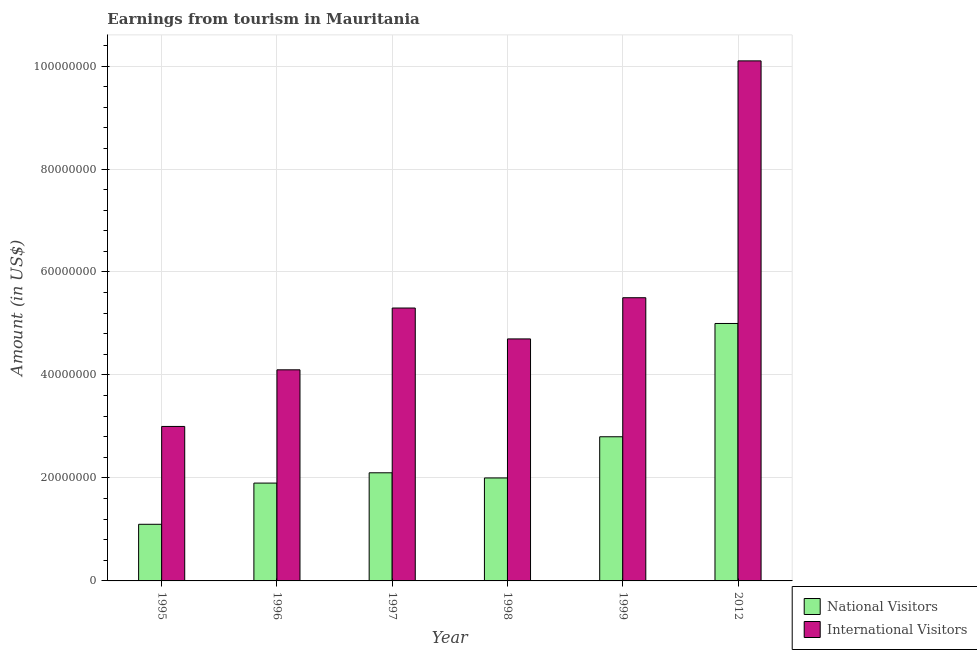Are the number of bars per tick equal to the number of legend labels?
Your response must be concise. Yes. Are the number of bars on each tick of the X-axis equal?
Make the answer very short. Yes. How many bars are there on the 4th tick from the left?
Provide a short and direct response. 2. What is the label of the 2nd group of bars from the left?
Make the answer very short. 1996. In how many cases, is the number of bars for a given year not equal to the number of legend labels?
Offer a terse response. 0. What is the amount earned from national visitors in 1997?
Offer a very short reply. 2.10e+07. Across all years, what is the maximum amount earned from international visitors?
Offer a very short reply. 1.01e+08. Across all years, what is the minimum amount earned from national visitors?
Make the answer very short. 1.10e+07. In which year was the amount earned from international visitors minimum?
Offer a very short reply. 1995. What is the total amount earned from national visitors in the graph?
Offer a terse response. 1.49e+08. What is the difference between the amount earned from national visitors in 1995 and that in 1999?
Keep it short and to the point. -1.70e+07. What is the difference between the amount earned from national visitors in 1996 and the amount earned from international visitors in 1995?
Your response must be concise. 8.00e+06. What is the average amount earned from international visitors per year?
Your response must be concise. 5.45e+07. In the year 1998, what is the difference between the amount earned from international visitors and amount earned from national visitors?
Your answer should be compact. 0. In how many years, is the amount earned from international visitors greater than 100000000 US$?
Your answer should be compact. 1. What is the ratio of the amount earned from international visitors in 1997 to that in 1998?
Your response must be concise. 1.13. What is the difference between the highest and the second highest amount earned from international visitors?
Offer a terse response. 4.60e+07. What is the difference between the highest and the lowest amount earned from international visitors?
Your answer should be compact. 7.10e+07. What does the 1st bar from the left in 1998 represents?
Keep it short and to the point. National Visitors. What does the 1st bar from the right in 2012 represents?
Provide a succinct answer. International Visitors. How many bars are there?
Your answer should be compact. 12. Are all the bars in the graph horizontal?
Provide a short and direct response. No. How many years are there in the graph?
Provide a succinct answer. 6. What is the difference between two consecutive major ticks on the Y-axis?
Provide a succinct answer. 2.00e+07. Are the values on the major ticks of Y-axis written in scientific E-notation?
Offer a terse response. No. Does the graph contain any zero values?
Your answer should be very brief. No. Does the graph contain grids?
Keep it short and to the point. Yes. How are the legend labels stacked?
Ensure brevity in your answer.  Vertical. What is the title of the graph?
Offer a very short reply. Earnings from tourism in Mauritania. What is the label or title of the X-axis?
Your answer should be compact. Year. What is the label or title of the Y-axis?
Ensure brevity in your answer.  Amount (in US$). What is the Amount (in US$) in National Visitors in 1995?
Your answer should be very brief. 1.10e+07. What is the Amount (in US$) in International Visitors in 1995?
Make the answer very short. 3.00e+07. What is the Amount (in US$) in National Visitors in 1996?
Keep it short and to the point. 1.90e+07. What is the Amount (in US$) in International Visitors in 1996?
Your answer should be very brief. 4.10e+07. What is the Amount (in US$) of National Visitors in 1997?
Provide a short and direct response. 2.10e+07. What is the Amount (in US$) of International Visitors in 1997?
Make the answer very short. 5.30e+07. What is the Amount (in US$) in International Visitors in 1998?
Make the answer very short. 4.70e+07. What is the Amount (in US$) of National Visitors in 1999?
Provide a succinct answer. 2.80e+07. What is the Amount (in US$) in International Visitors in 1999?
Your answer should be very brief. 5.50e+07. What is the Amount (in US$) in International Visitors in 2012?
Offer a very short reply. 1.01e+08. Across all years, what is the maximum Amount (in US$) of International Visitors?
Provide a short and direct response. 1.01e+08. Across all years, what is the minimum Amount (in US$) in National Visitors?
Provide a succinct answer. 1.10e+07. Across all years, what is the minimum Amount (in US$) of International Visitors?
Offer a terse response. 3.00e+07. What is the total Amount (in US$) of National Visitors in the graph?
Keep it short and to the point. 1.49e+08. What is the total Amount (in US$) in International Visitors in the graph?
Provide a short and direct response. 3.27e+08. What is the difference between the Amount (in US$) in National Visitors in 1995 and that in 1996?
Your answer should be compact. -8.00e+06. What is the difference between the Amount (in US$) of International Visitors in 1995 and that in 1996?
Offer a terse response. -1.10e+07. What is the difference between the Amount (in US$) of National Visitors in 1995 and that in 1997?
Give a very brief answer. -1.00e+07. What is the difference between the Amount (in US$) in International Visitors in 1995 and that in 1997?
Your answer should be very brief. -2.30e+07. What is the difference between the Amount (in US$) in National Visitors in 1995 and that in 1998?
Ensure brevity in your answer.  -9.00e+06. What is the difference between the Amount (in US$) in International Visitors in 1995 and that in 1998?
Keep it short and to the point. -1.70e+07. What is the difference between the Amount (in US$) in National Visitors in 1995 and that in 1999?
Make the answer very short. -1.70e+07. What is the difference between the Amount (in US$) in International Visitors in 1995 and that in 1999?
Keep it short and to the point. -2.50e+07. What is the difference between the Amount (in US$) of National Visitors in 1995 and that in 2012?
Provide a short and direct response. -3.90e+07. What is the difference between the Amount (in US$) of International Visitors in 1995 and that in 2012?
Give a very brief answer. -7.10e+07. What is the difference between the Amount (in US$) of National Visitors in 1996 and that in 1997?
Make the answer very short. -2.00e+06. What is the difference between the Amount (in US$) of International Visitors in 1996 and that in 1997?
Keep it short and to the point. -1.20e+07. What is the difference between the Amount (in US$) in International Visitors in 1996 and that in 1998?
Ensure brevity in your answer.  -6.00e+06. What is the difference between the Amount (in US$) of National Visitors in 1996 and that in 1999?
Make the answer very short. -9.00e+06. What is the difference between the Amount (in US$) of International Visitors in 1996 and that in 1999?
Your answer should be compact. -1.40e+07. What is the difference between the Amount (in US$) of National Visitors in 1996 and that in 2012?
Offer a very short reply. -3.10e+07. What is the difference between the Amount (in US$) of International Visitors in 1996 and that in 2012?
Your answer should be very brief. -6.00e+07. What is the difference between the Amount (in US$) in National Visitors in 1997 and that in 1999?
Keep it short and to the point. -7.00e+06. What is the difference between the Amount (in US$) in International Visitors in 1997 and that in 1999?
Your answer should be compact. -2.00e+06. What is the difference between the Amount (in US$) in National Visitors in 1997 and that in 2012?
Offer a very short reply. -2.90e+07. What is the difference between the Amount (in US$) in International Visitors in 1997 and that in 2012?
Offer a terse response. -4.80e+07. What is the difference between the Amount (in US$) of National Visitors in 1998 and that in 1999?
Your answer should be compact. -8.00e+06. What is the difference between the Amount (in US$) in International Visitors in 1998 and that in 1999?
Provide a short and direct response. -8.00e+06. What is the difference between the Amount (in US$) in National Visitors in 1998 and that in 2012?
Provide a succinct answer. -3.00e+07. What is the difference between the Amount (in US$) in International Visitors in 1998 and that in 2012?
Keep it short and to the point. -5.40e+07. What is the difference between the Amount (in US$) in National Visitors in 1999 and that in 2012?
Keep it short and to the point. -2.20e+07. What is the difference between the Amount (in US$) in International Visitors in 1999 and that in 2012?
Keep it short and to the point. -4.60e+07. What is the difference between the Amount (in US$) of National Visitors in 1995 and the Amount (in US$) of International Visitors in 1996?
Offer a terse response. -3.00e+07. What is the difference between the Amount (in US$) of National Visitors in 1995 and the Amount (in US$) of International Visitors in 1997?
Ensure brevity in your answer.  -4.20e+07. What is the difference between the Amount (in US$) in National Visitors in 1995 and the Amount (in US$) in International Visitors in 1998?
Offer a very short reply. -3.60e+07. What is the difference between the Amount (in US$) in National Visitors in 1995 and the Amount (in US$) in International Visitors in 1999?
Provide a succinct answer. -4.40e+07. What is the difference between the Amount (in US$) of National Visitors in 1995 and the Amount (in US$) of International Visitors in 2012?
Your answer should be very brief. -9.00e+07. What is the difference between the Amount (in US$) in National Visitors in 1996 and the Amount (in US$) in International Visitors in 1997?
Offer a very short reply. -3.40e+07. What is the difference between the Amount (in US$) of National Visitors in 1996 and the Amount (in US$) of International Visitors in 1998?
Keep it short and to the point. -2.80e+07. What is the difference between the Amount (in US$) in National Visitors in 1996 and the Amount (in US$) in International Visitors in 1999?
Keep it short and to the point. -3.60e+07. What is the difference between the Amount (in US$) in National Visitors in 1996 and the Amount (in US$) in International Visitors in 2012?
Your response must be concise. -8.20e+07. What is the difference between the Amount (in US$) of National Visitors in 1997 and the Amount (in US$) of International Visitors in 1998?
Provide a succinct answer. -2.60e+07. What is the difference between the Amount (in US$) of National Visitors in 1997 and the Amount (in US$) of International Visitors in 1999?
Provide a succinct answer. -3.40e+07. What is the difference between the Amount (in US$) of National Visitors in 1997 and the Amount (in US$) of International Visitors in 2012?
Provide a short and direct response. -8.00e+07. What is the difference between the Amount (in US$) of National Visitors in 1998 and the Amount (in US$) of International Visitors in 1999?
Provide a short and direct response. -3.50e+07. What is the difference between the Amount (in US$) in National Visitors in 1998 and the Amount (in US$) in International Visitors in 2012?
Ensure brevity in your answer.  -8.10e+07. What is the difference between the Amount (in US$) in National Visitors in 1999 and the Amount (in US$) in International Visitors in 2012?
Make the answer very short. -7.30e+07. What is the average Amount (in US$) of National Visitors per year?
Give a very brief answer. 2.48e+07. What is the average Amount (in US$) in International Visitors per year?
Ensure brevity in your answer.  5.45e+07. In the year 1995, what is the difference between the Amount (in US$) of National Visitors and Amount (in US$) of International Visitors?
Keep it short and to the point. -1.90e+07. In the year 1996, what is the difference between the Amount (in US$) of National Visitors and Amount (in US$) of International Visitors?
Give a very brief answer. -2.20e+07. In the year 1997, what is the difference between the Amount (in US$) in National Visitors and Amount (in US$) in International Visitors?
Your answer should be very brief. -3.20e+07. In the year 1998, what is the difference between the Amount (in US$) in National Visitors and Amount (in US$) in International Visitors?
Give a very brief answer. -2.70e+07. In the year 1999, what is the difference between the Amount (in US$) in National Visitors and Amount (in US$) in International Visitors?
Keep it short and to the point. -2.70e+07. In the year 2012, what is the difference between the Amount (in US$) of National Visitors and Amount (in US$) of International Visitors?
Provide a succinct answer. -5.10e+07. What is the ratio of the Amount (in US$) in National Visitors in 1995 to that in 1996?
Make the answer very short. 0.58. What is the ratio of the Amount (in US$) in International Visitors in 1995 to that in 1996?
Give a very brief answer. 0.73. What is the ratio of the Amount (in US$) of National Visitors in 1995 to that in 1997?
Your answer should be compact. 0.52. What is the ratio of the Amount (in US$) in International Visitors in 1995 to that in 1997?
Offer a very short reply. 0.57. What is the ratio of the Amount (in US$) of National Visitors in 1995 to that in 1998?
Your answer should be very brief. 0.55. What is the ratio of the Amount (in US$) in International Visitors in 1995 to that in 1998?
Ensure brevity in your answer.  0.64. What is the ratio of the Amount (in US$) of National Visitors in 1995 to that in 1999?
Provide a succinct answer. 0.39. What is the ratio of the Amount (in US$) of International Visitors in 1995 to that in 1999?
Provide a short and direct response. 0.55. What is the ratio of the Amount (in US$) of National Visitors in 1995 to that in 2012?
Your response must be concise. 0.22. What is the ratio of the Amount (in US$) of International Visitors in 1995 to that in 2012?
Provide a succinct answer. 0.3. What is the ratio of the Amount (in US$) of National Visitors in 1996 to that in 1997?
Your answer should be compact. 0.9. What is the ratio of the Amount (in US$) of International Visitors in 1996 to that in 1997?
Offer a terse response. 0.77. What is the ratio of the Amount (in US$) in National Visitors in 1996 to that in 1998?
Your answer should be very brief. 0.95. What is the ratio of the Amount (in US$) in International Visitors in 1996 to that in 1998?
Ensure brevity in your answer.  0.87. What is the ratio of the Amount (in US$) in National Visitors in 1996 to that in 1999?
Ensure brevity in your answer.  0.68. What is the ratio of the Amount (in US$) of International Visitors in 1996 to that in 1999?
Your answer should be very brief. 0.75. What is the ratio of the Amount (in US$) of National Visitors in 1996 to that in 2012?
Your answer should be compact. 0.38. What is the ratio of the Amount (in US$) of International Visitors in 1996 to that in 2012?
Give a very brief answer. 0.41. What is the ratio of the Amount (in US$) in International Visitors in 1997 to that in 1998?
Ensure brevity in your answer.  1.13. What is the ratio of the Amount (in US$) of International Visitors in 1997 to that in 1999?
Ensure brevity in your answer.  0.96. What is the ratio of the Amount (in US$) of National Visitors in 1997 to that in 2012?
Give a very brief answer. 0.42. What is the ratio of the Amount (in US$) in International Visitors in 1997 to that in 2012?
Your response must be concise. 0.52. What is the ratio of the Amount (in US$) of National Visitors in 1998 to that in 1999?
Give a very brief answer. 0.71. What is the ratio of the Amount (in US$) of International Visitors in 1998 to that in 1999?
Give a very brief answer. 0.85. What is the ratio of the Amount (in US$) of International Visitors in 1998 to that in 2012?
Your answer should be very brief. 0.47. What is the ratio of the Amount (in US$) of National Visitors in 1999 to that in 2012?
Give a very brief answer. 0.56. What is the ratio of the Amount (in US$) in International Visitors in 1999 to that in 2012?
Make the answer very short. 0.54. What is the difference between the highest and the second highest Amount (in US$) of National Visitors?
Your answer should be compact. 2.20e+07. What is the difference between the highest and the second highest Amount (in US$) in International Visitors?
Provide a succinct answer. 4.60e+07. What is the difference between the highest and the lowest Amount (in US$) of National Visitors?
Your answer should be very brief. 3.90e+07. What is the difference between the highest and the lowest Amount (in US$) of International Visitors?
Your response must be concise. 7.10e+07. 